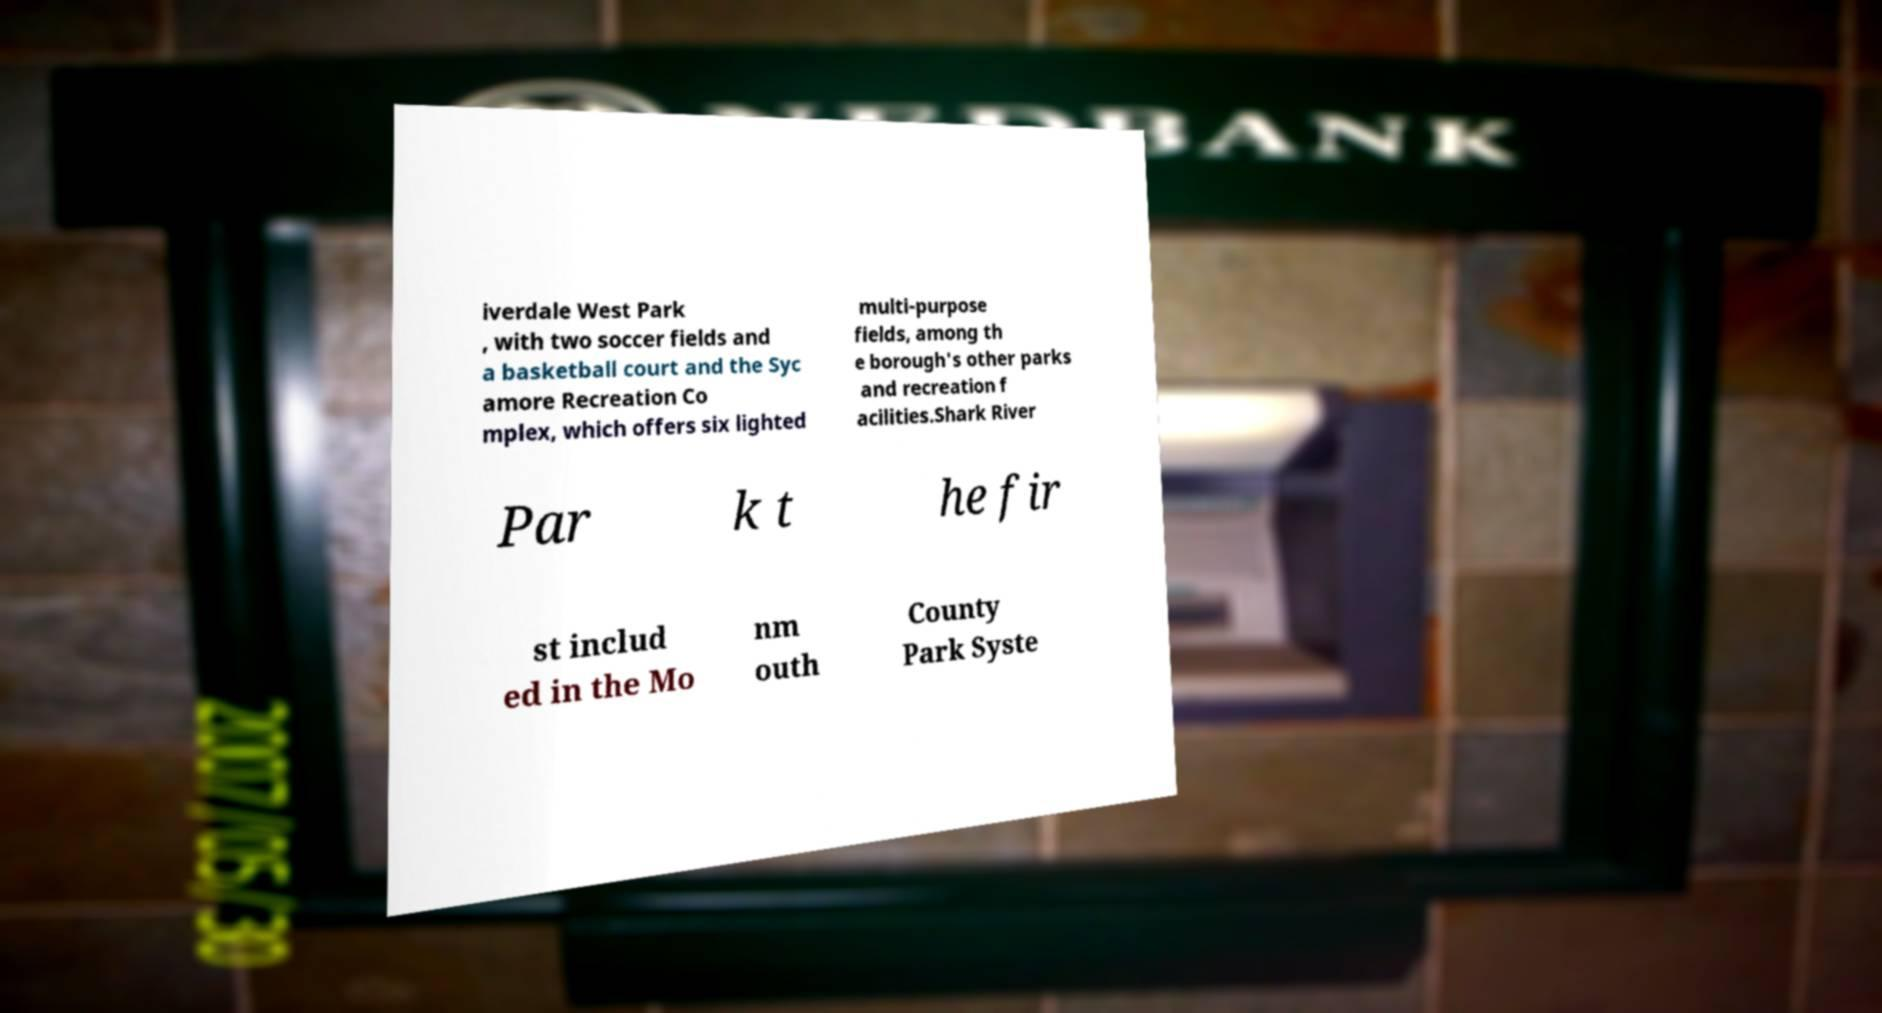Please identify and transcribe the text found in this image. iverdale West Park , with two soccer fields and a basketball court and the Syc amore Recreation Co mplex, which offers six lighted multi-purpose fields, among th e borough's other parks and recreation f acilities.Shark River Par k t he fir st includ ed in the Mo nm outh County Park Syste 